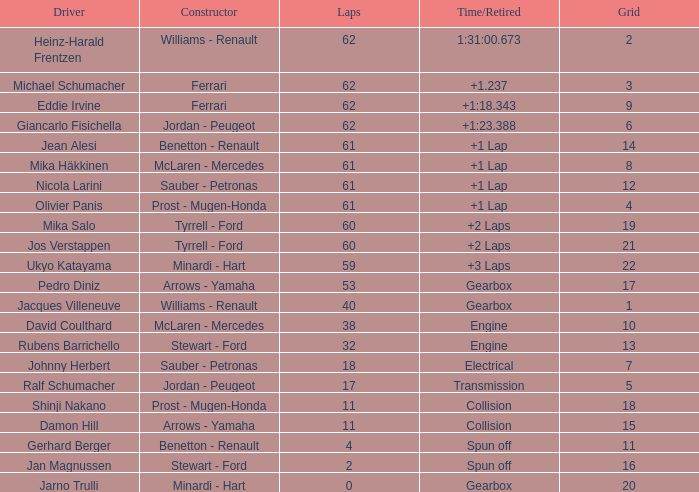What constructor has under 62 laps, a Time/Retired of gearbox, a Grid larger than 1, and pedro diniz driving? Arrows - Yamaha. Parse the full table. {'header': ['Driver', 'Constructor', 'Laps', 'Time/Retired', 'Grid'], 'rows': [['Heinz-Harald Frentzen', 'Williams - Renault', '62', '1:31:00.673', '2'], ['Michael Schumacher', 'Ferrari', '62', '+1.237', '3'], ['Eddie Irvine', 'Ferrari', '62', '+1:18.343', '9'], ['Giancarlo Fisichella', 'Jordan - Peugeot', '62', '+1:23.388', '6'], ['Jean Alesi', 'Benetton - Renault', '61', '+1 Lap', '14'], ['Mika Häkkinen', 'McLaren - Mercedes', '61', '+1 Lap', '8'], ['Nicola Larini', 'Sauber - Petronas', '61', '+1 Lap', '12'], ['Olivier Panis', 'Prost - Mugen-Honda', '61', '+1 Lap', '4'], ['Mika Salo', 'Tyrrell - Ford', '60', '+2 Laps', '19'], ['Jos Verstappen', 'Tyrrell - Ford', '60', '+2 Laps', '21'], ['Ukyo Katayama', 'Minardi - Hart', '59', '+3 Laps', '22'], ['Pedro Diniz', 'Arrows - Yamaha', '53', 'Gearbox', '17'], ['Jacques Villeneuve', 'Williams - Renault', '40', 'Gearbox', '1'], ['David Coulthard', 'McLaren - Mercedes', '38', 'Engine', '10'], ['Rubens Barrichello', 'Stewart - Ford', '32', 'Engine', '13'], ['Johnny Herbert', 'Sauber - Petronas', '18', 'Electrical', '7'], ['Ralf Schumacher', 'Jordan - Peugeot', '17', 'Transmission', '5'], ['Shinji Nakano', 'Prost - Mugen-Honda', '11', 'Collision', '18'], ['Damon Hill', 'Arrows - Yamaha', '11', 'Collision', '15'], ['Gerhard Berger', 'Benetton - Renault', '4', 'Spun off', '11'], ['Jan Magnussen', 'Stewart - Ford', '2', 'Spun off', '16'], ['Jarno Trulli', 'Minardi - Hart', '0', 'Gearbox', '20']]} 